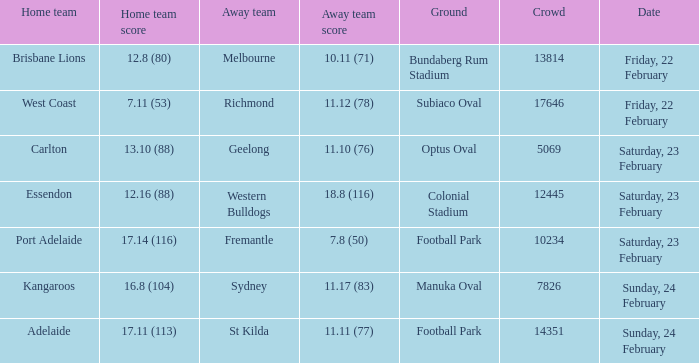With the home team scoring 1 5069.0. 